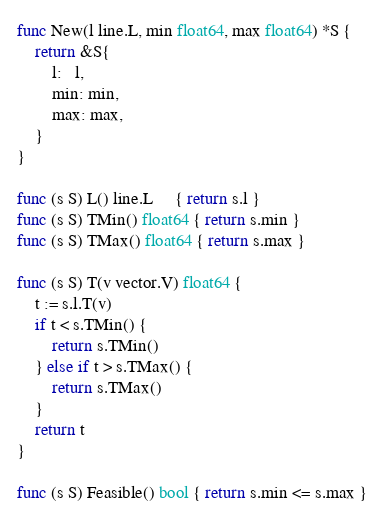Convert code to text. <code><loc_0><loc_0><loc_500><loc_500><_Go_>func New(l line.L, min float64, max float64) *S {
	return &S{
		l:   l,
		min: min,
		max: max,
	}
}

func (s S) L() line.L     { return s.l }
func (s S) TMin() float64 { return s.min }
func (s S) TMax() float64 { return s.max }

func (s S) T(v vector.V) float64 {
	t := s.l.T(v)
	if t < s.TMin() {
		return s.TMin()
	} else if t > s.TMax() {
		return s.TMax()
	}
	return t
}

func (s S) Feasible() bool { return s.min <= s.max }
</code> 